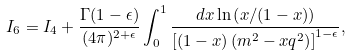<formula> <loc_0><loc_0><loc_500><loc_500>I _ { 6 } = I _ { 4 } + \frac { \Gamma ( 1 - \epsilon ) } { ( 4 \pi ) ^ { 2 + \epsilon } } \int _ { 0 } ^ { 1 } \frac { d x \ln \left ( x / ( 1 - x ) \right ) } { \left [ ( 1 - x ) \left ( m ^ { 2 } - x q ^ { 2 } \right ) \right ] ^ { 1 - \epsilon } } ,</formula> 